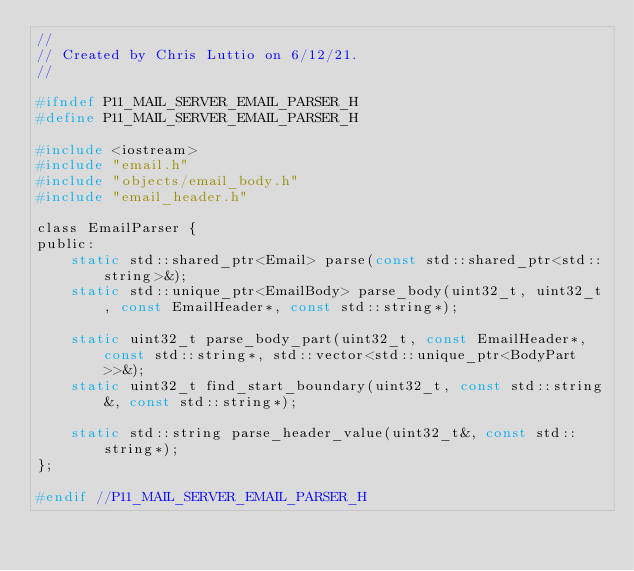<code> <loc_0><loc_0><loc_500><loc_500><_C_>//
// Created by Chris Luttio on 6/12/21.
//

#ifndef P11_MAIL_SERVER_EMAIL_PARSER_H
#define P11_MAIL_SERVER_EMAIL_PARSER_H

#include <iostream>
#include "email.h"
#include "objects/email_body.h"
#include "email_header.h"

class EmailParser {
public:
    static std::shared_ptr<Email> parse(const std::shared_ptr<std::string>&);
    static std::unique_ptr<EmailBody> parse_body(uint32_t, uint32_t, const EmailHeader*, const std::string*);

    static uint32_t parse_body_part(uint32_t, const EmailHeader*, const std::string*, std::vector<std::unique_ptr<BodyPart>>&);
    static uint32_t find_start_boundary(uint32_t, const std::string&, const std::string*);

    static std::string parse_header_value(uint32_t&, const std::string*);
};

#endif //P11_MAIL_SERVER_EMAIL_PARSER_H
</code> 